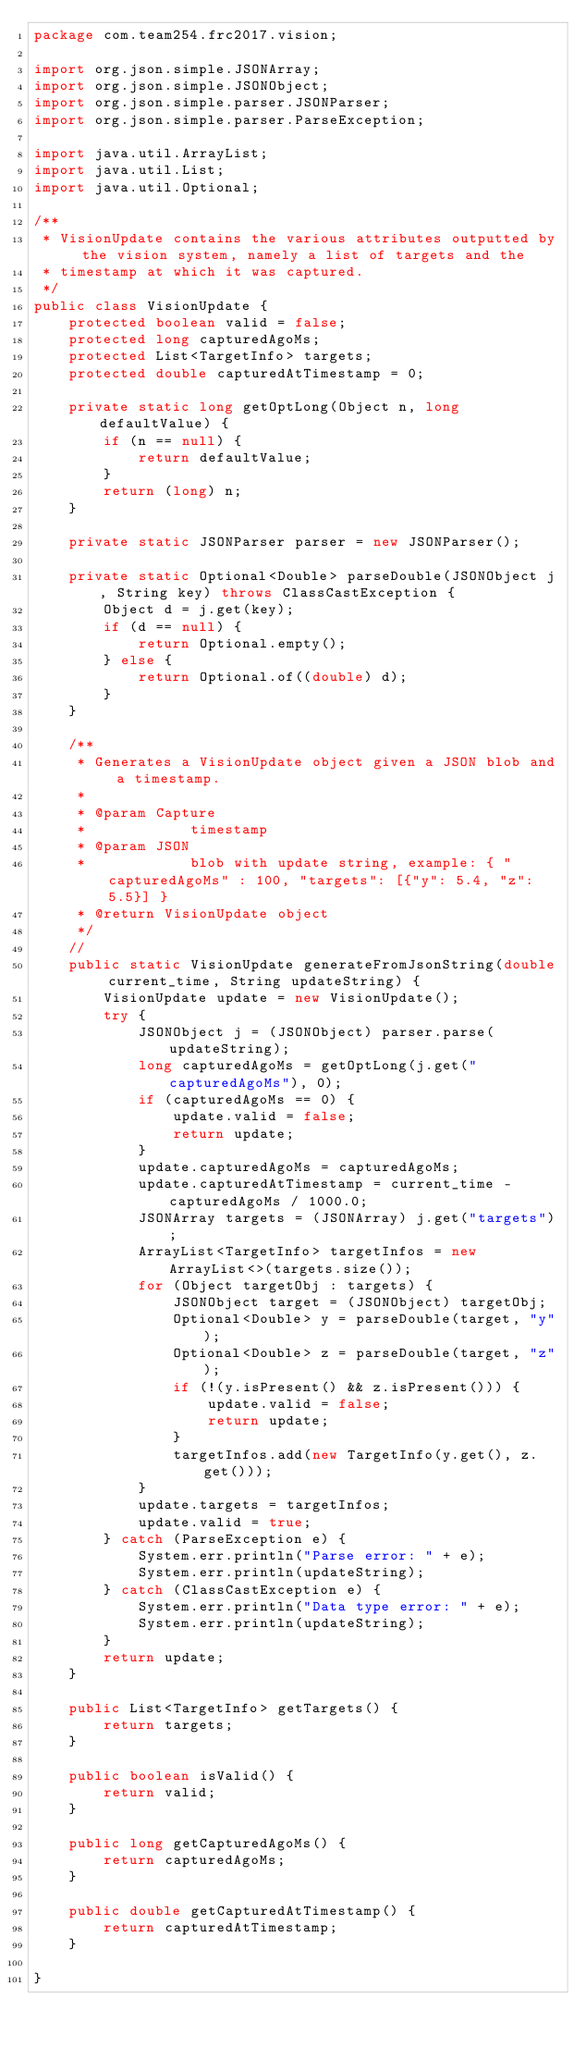Convert code to text. <code><loc_0><loc_0><loc_500><loc_500><_Java_>package com.team254.frc2017.vision;

import org.json.simple.JSONArray;
import org.json.simple.JSONObject;
import org.json.simple.parser.JSONParser;
import org.json.simple.parser.ParseException;

import java.util.ArrayList;
import java.util.List;
import java.util.Optional;

/**
 * VisionUpdate contains the various attributes outputted by the vision system, namely a list of targets and the
 * timestamp at which it was captured.
 */
public class VisionUpdate {
    protected boolean valid = false;
    protected long capturedAgoMs;
    protected List<TargetInfo> targets;
    protected double capturedAtTimestamp = 0;

    private static long getOptLong(Object n, long defaultValue) {
        if (n == null) {
            return defaultValue;
        }
        return (long) n;
    }

    private static JSONParser parser = new JSONParser();

    private static Optional<Double> parseDouble(JSONObject j, String key) throws ClassCastException {
        Object d = j.get(key);
        if (d == null) {
            return Optional.empty();
        } else {
            return Optional.of((double) d);
        }
    }

    /**
     * Generates a VisionUpdate object given a JSON blob and a timestamp.
     * 
     * @param Capture
     *            timestamp
     * @param JSON
     *            blob with update string, example: { "capturedAgoMs" : 100, "targets": [{"y": 5.4, "z": 5.5}] }
     * @return VisionUpdate object
     */
    //
    public static VisionUpdate generateFromJsonString(double current_time, String updateString) {
        VisionUpdate update = new VisionUpdate();
        try {
            JSONObject j = (JSONObject) parser.parse(updateString);
            long capturedAgoMs = getOptLong(j.get("capturedAgoMs"), 0);
            if (capturedAgoMs == 0) {
                update.valid = false;
                return update;
            }
            update.capturedAgoMs = capturedAgoMs;
            update.capturedAtTimestamp = current_time - capturedAgoMs / 1000.0;
            JSONArray targets = (JSONArray) j.get("targets");
            ArrayList<TargetInfo> targetInfos = new ArrayList<>(targets.size());
            for (Object targetObj : targets) {
                JSONObject target = (JSONObject) targetObj;
                Optional<Double> y = parseDouble(target, "y");
                Optional<Double> z = parseDouble(target, "z");
                if (!(y.isPresent() && z.isPresent())) {
                    update.valid = false;
                    return update;
                }
                targetInfos.add(new TargetInfo(y.get(), z.get()));
            }
            update.targets = targetInfos;
            update.valid = true;
        } catch (ParseException e) {
            System.err.println("Parse error: " + e);
            System.err.println(updateString);
        } catch (ClassCastException e) {
            System.err.println("Data type error: " + e);
            System.err.println(updateString);
        }
        return update;
    }

    public List<TargetInfo> getTargets() {
        return targets;
    }

    public boolean isValid() {
        return valid;
    }

    public long getCapturedAgoMs() {
        return capturedAgoMs;
    }

    public double getCapturedAtTimestamp() {
        return capturedAtTimestamp;
    }

}
</code> 